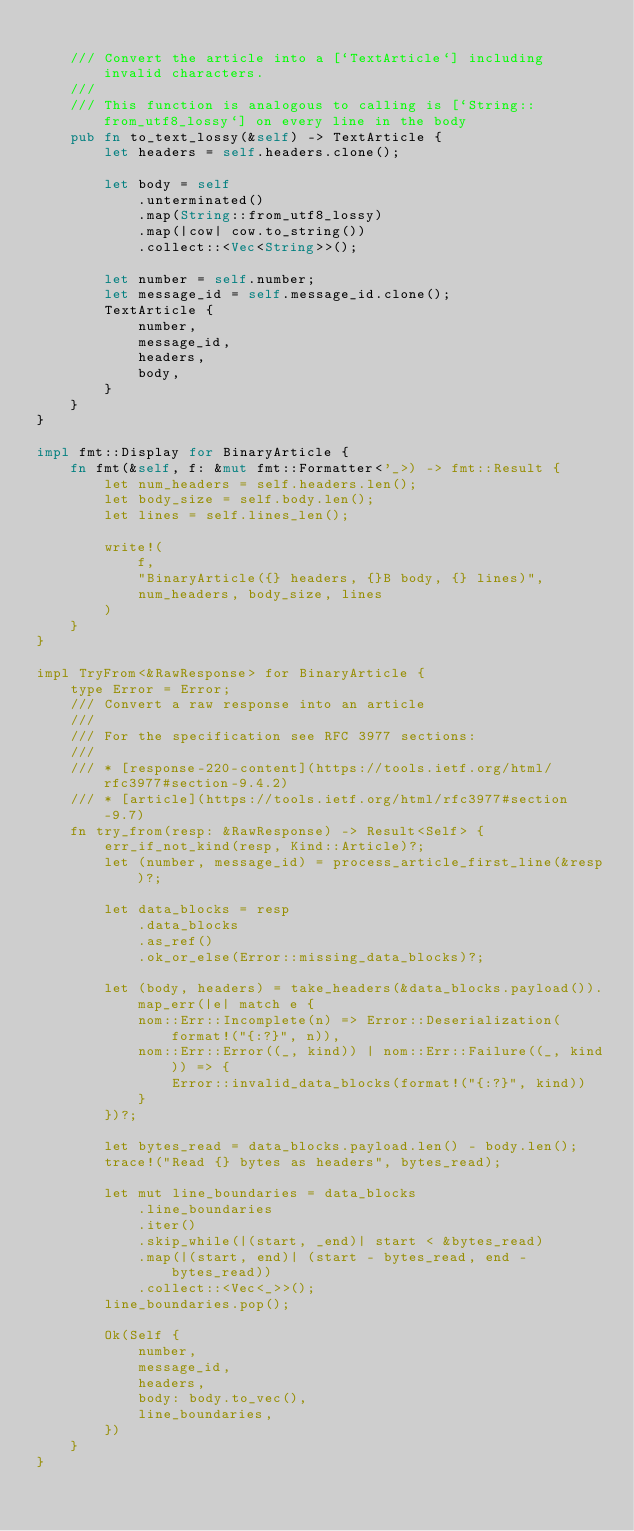<code> <loc_0><loc_0><loc_500><loc_500><_Rust_>
    /// Convert the article into a [`TextArticle`] including invalid characters.
    ///
    /// This function is analogous to calling is [`String::from_utf8_lossy`] on every line in the body
    pub fn to_text_lossy(&self) -> TextArticle {
        let headers = self.headers.clone();

        let body = self
            .unterminated()
            .map(String::from_utf8_lossy)
            .map(|cow| cow.to_string())
            .collect::<Vec<String>>();

        let number = self.number;
        let message_id = self.message_id.clone();
        TextArticle {
            number,
            message_id,
            headers,
            body,
        }
    }
}

impl fmt::Display for BinaryArticle {
    fn fmt(&self, f: &mut fmt::Formatter<'_>) -> fmt::Result {
        let num_headers = self.headers.len();
        let body_size = self.body.len();
        let lines = self.lines_len();

        write!(
            f,
            "BinaryArticle({} headers, {}B body, {} lines)",
            num_headers, body_size, lines
        )
    }
}

impl TryFrom<&RawResponse> for BinaryArticle {
    type Error = Error;
    /// Convert a raw response into an article
    ///
    /// For the specification see RFC 3977 sections:
    ///
    /// * [response-220-content](https://tools.ietf.org/html/rfc3977#section-9.4.2)
    /// * [article](https://tools.ietf.org/html/rfc3977#section-9.7)
    fn try_from(resp: &RawResponse) -> Result<Self> {
        err_if_not_kind(resp, Kind::Article)?;
        let (number, message_id) = process_article_first_line(&resp)?;

        let data_blocks = resp
            .data_blocks
            .as_ref()
            .ok_or_else(Error::missing_data_blocks)?;

        let (body, headers) = take_headers(&data_blocks.payload()).map_err(|e| match e {
            nom::Err::Incomplete(n) => Error::Deserialization(format!("{:?}", n)),
            nom::Err::Error((_, kind)) | nom::Err::Failure((_, kind)) => {
                Error::invalid_data_blocks(format!("{:?}", kind))
            }
        })?;

        let bytes_read = data_blocks.payload.len() - body.len();
        trace!("Read {} bytes as headers", bytes_read);

        let mut line_boundaries = data_blocks
            .line_boundaries
            .iter()
            .skip_while(|(start, _end)| start < &bytes_read)
            .map(|(start, end)| (start - bytes_read, end - bytes_read))
            .collect::<Vec<_>>();
        line_boundaries.pop();

        Ok(Self {
            number,
            message_id,
            headers,
            body: body.to_vec(),
            line_boundaries,
        })
    }
}
</code> 